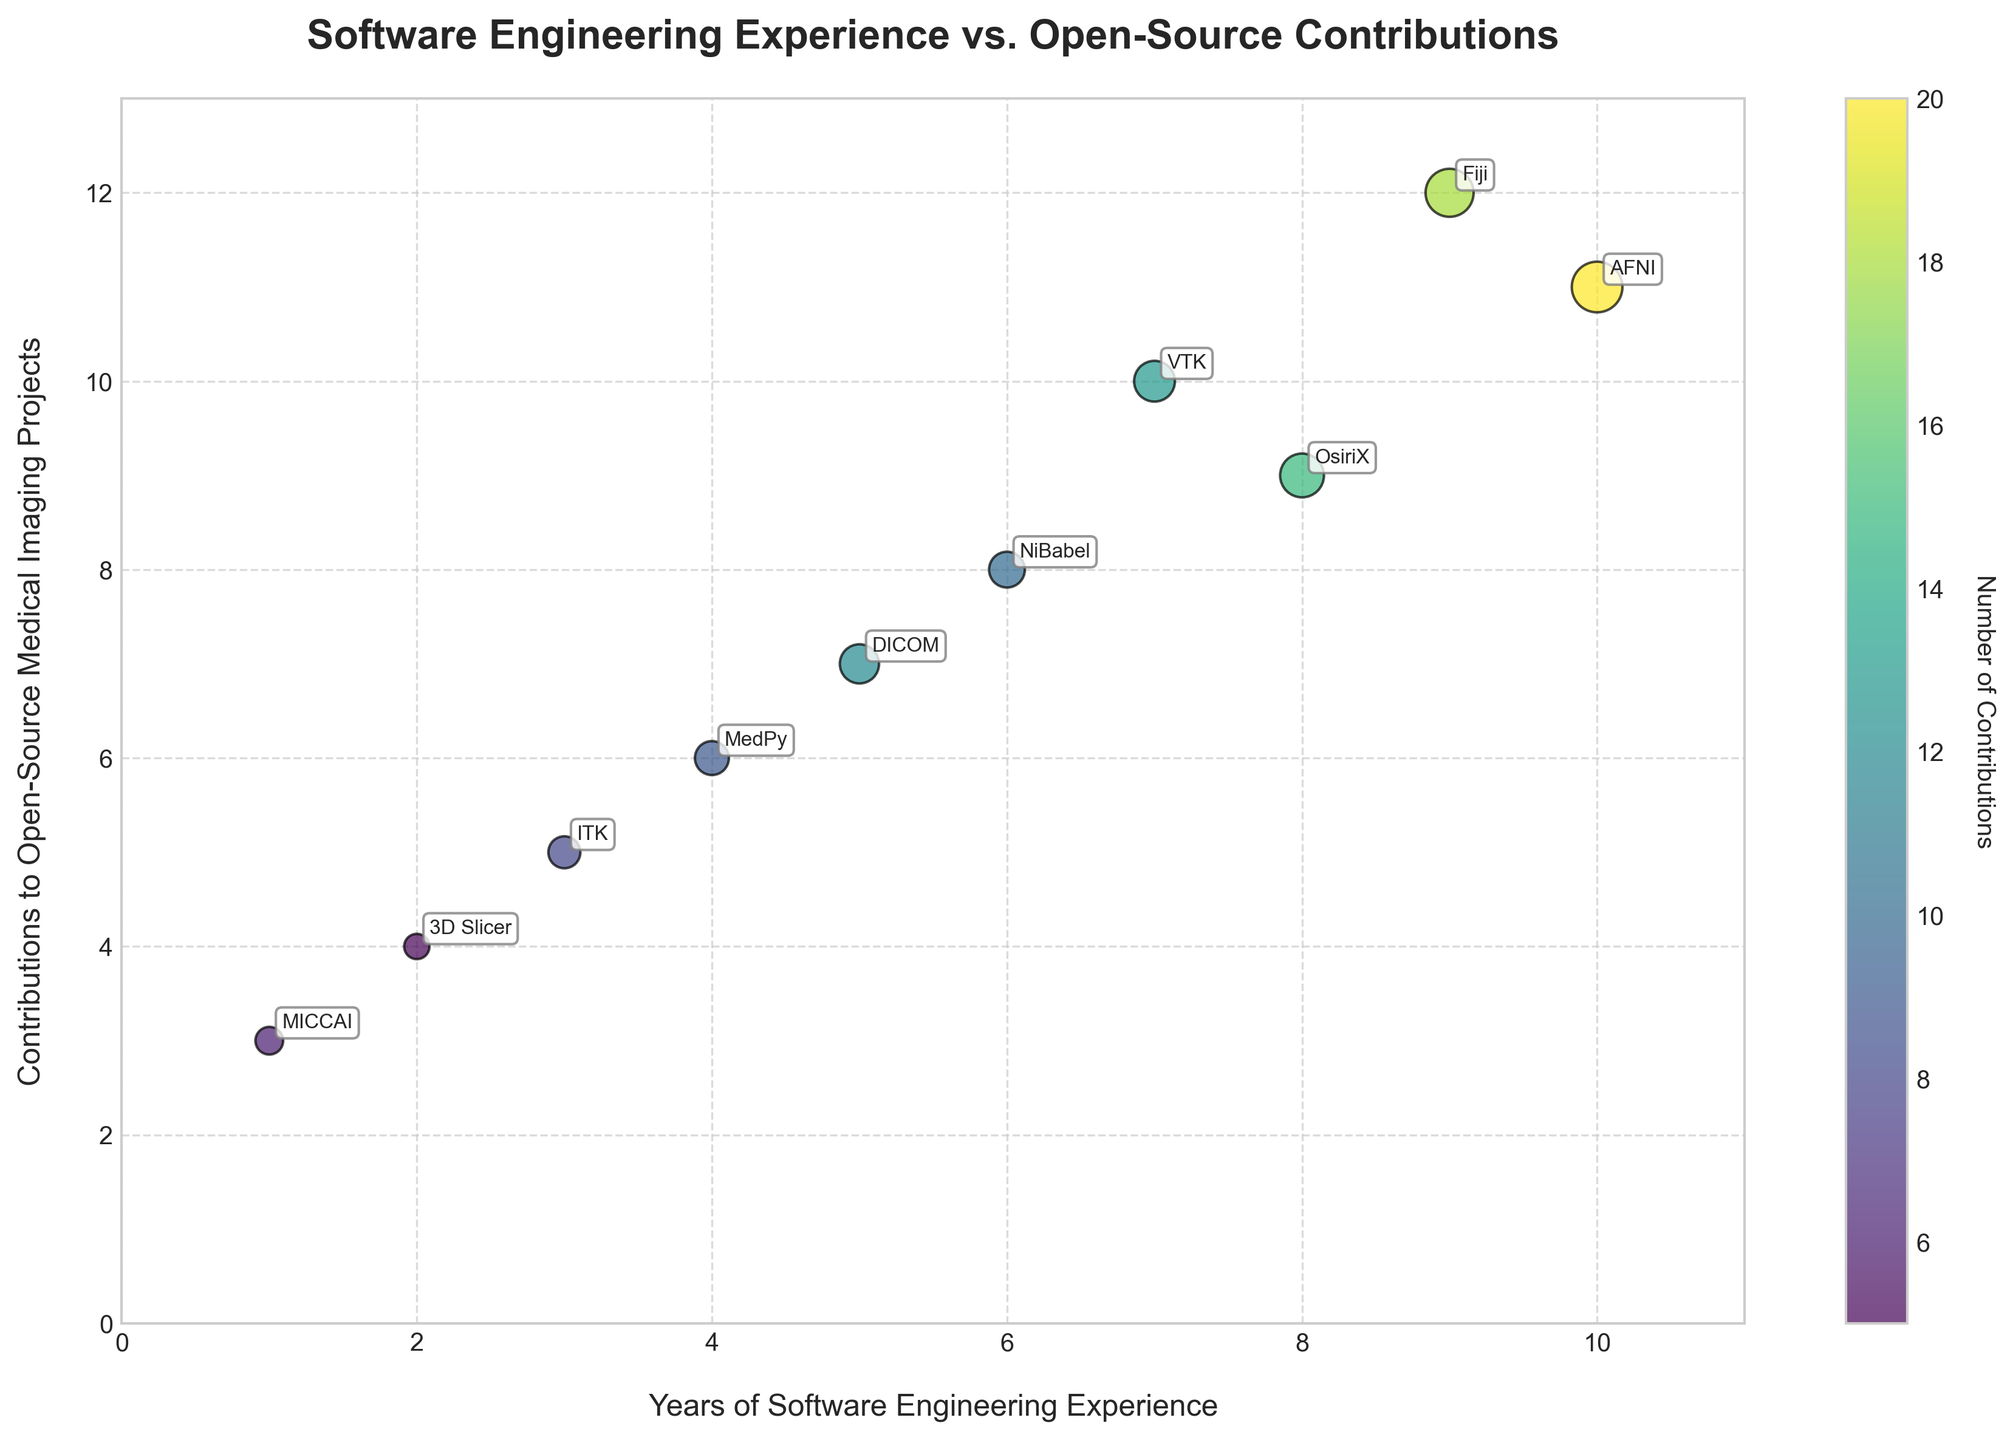What is the title of the plot? The title is displayed at the top of the plot and reads, "Software Engineering Experience vs. Open-Source Contributions."
Answer: Software Engineering Experience vs. Open-Source Contributions How many data points are shown in the plot? Each bubble represents a data point, and visual inspection reveals that there are 10 bubbles in total, one for each software project listed in the data.
Answer: 10 Which project has the highest number of contributions? By looking at the bubble size and the information provided visually, we see that the project with the highest number of contributions is labeled 'AFNI' with 20 contributions.
Answer: AFNI What is the color bar label, and what does it signify? The color bar on the right side of the plot is labeled 'Number of Contributions,' indicating that the color intensity of the bubbles represents the number of contributions to each project.
Answer: Number of Contributions How many projects have been contributed to by a software engineer with 5 years of experience? By examining the plot, we see that the 'DICOM' project is located at 5 years of experience.
Answer: 1 Which project has a software engineer with 7 years of experience, and how many contributions were made? Observing the bubble positioned at 7 years of experience and examining the annotation, the project is 'VTK,' and it had 13 contributions.
Answer: VTK What's the average number of contributions across all projects? Summing the number of contributions made to each project (8 + 12 + 5 + 15 + 20 + 6 + 10 + 9 + 13 + 18) results in 116. With 10 projects, the average is 116/10.
Answer: 11.6 Which two projects have the closest number of contributions, and what are their differences? 'MedPy' (9 contributions) and 'NiBabel' (10 contributions) have the closest contributions. The difference is 10 - 9.
Answer: MedPy and NiBabel, 1 Which project is associated with the least experienced software engineer, and how many years of experience do they have? The project 'MICCAI' is located at 1 year of experience, making it associated with the least experienced software engineer.
Answer: MICCAI, 1 year How are the projects distributed across different software engineering experience levels? By scanning from left to right along the x-axis, the projects span from 1 year to 10 years of experience, showing a relatively balanced distribution over time.
Answer: Even distribution across 1-10 years 